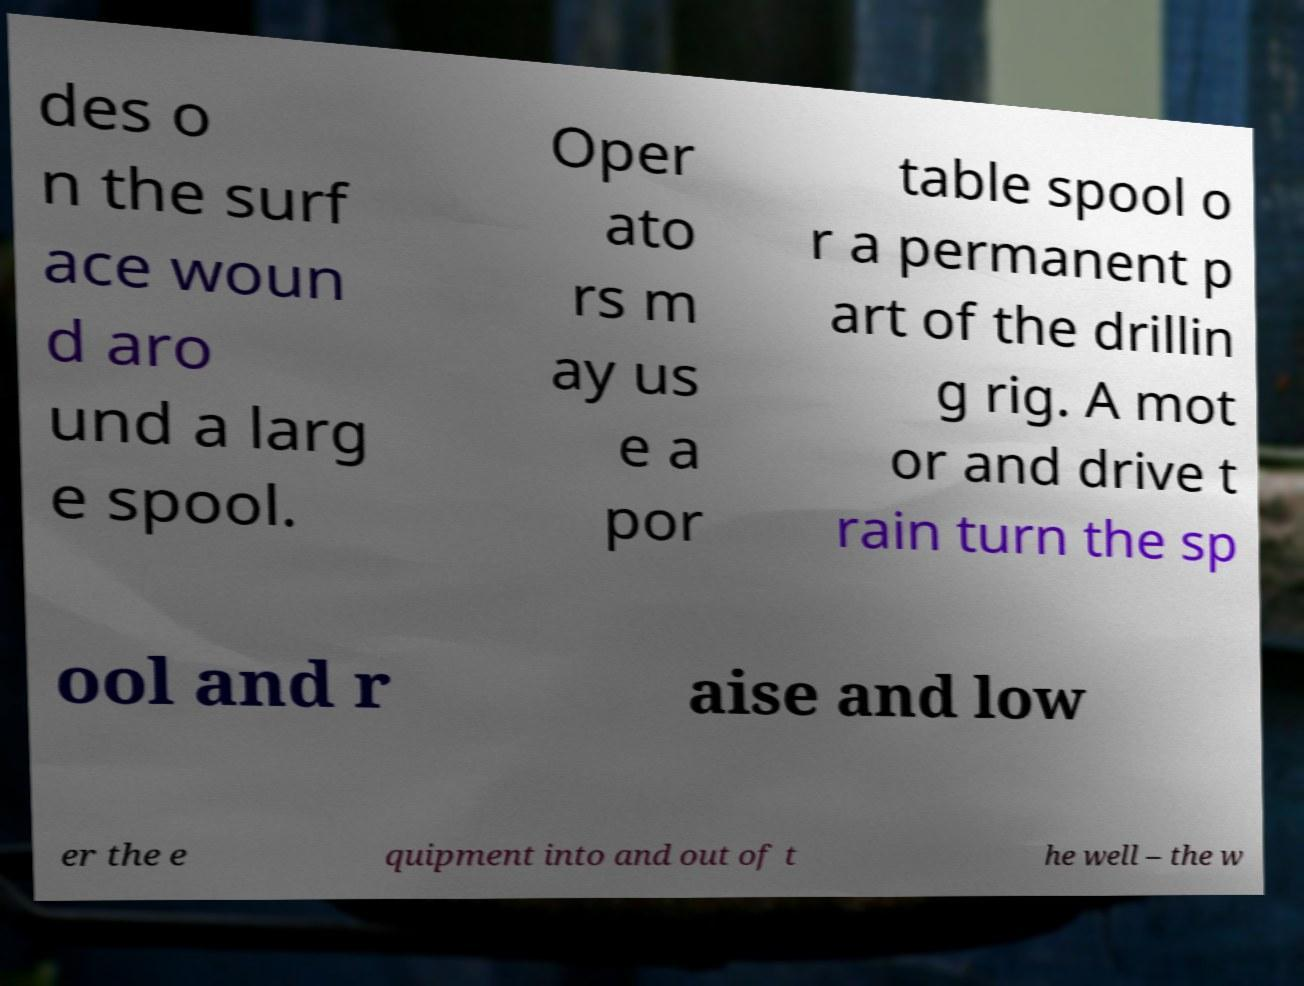Please identify and transcribe the text found in this image. des o n the surf ace woun d aro und a larg e spool. Oper ato rs m ay us e a por table spool o r a permanent p art of the drillin g rig. A mot or and drive t rain turn the sp ool and r aise and low er the e quipment into and out of t he well – the w 